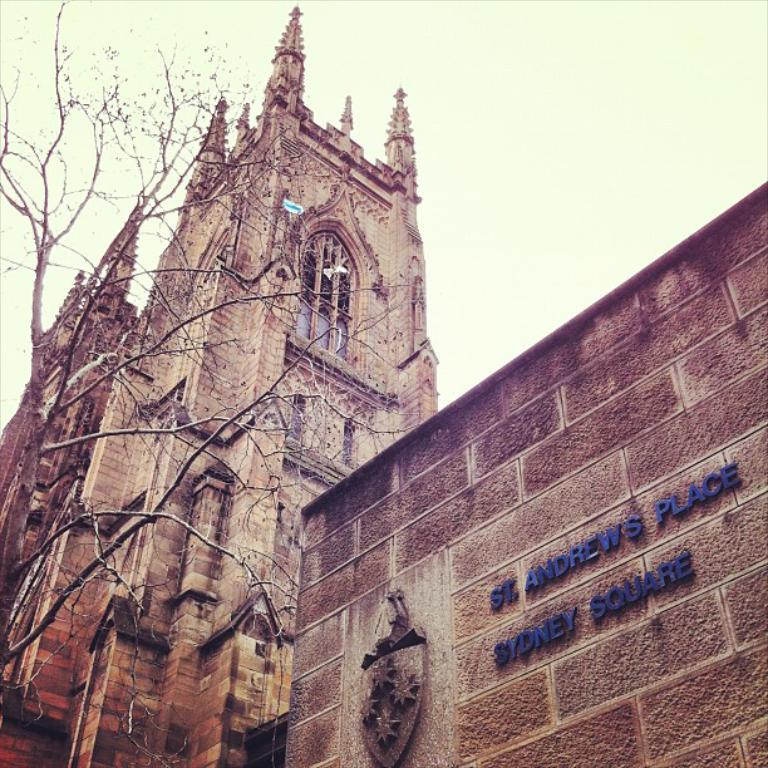What type of structure can be seen in the image? There is a building in the image. What else is present in the image besides the building? There is a wall, a tree, and the sky visible in the image. Can you describe the natural element in the image? There is a tree in the image. What is visible in the background of the image? The sky is visible in the image. How many legs does the tree have in the image? Trees do not have legs; they have trunks and branches. In the image, the tree has a trunk and branches, but no legs. 